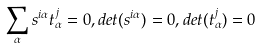Convert formula to latex. <formula><loc_0><loc_0><loc_500><loc_500>\sum _ { \alpha } s ^ { i \alpha } t ^ { j } _ { \alpha } = 0 , d e t ( s ^ { i \alpha } ) = 0 , d e t ( t ^ { j } _ { \alpha } ) = 0</formula> 